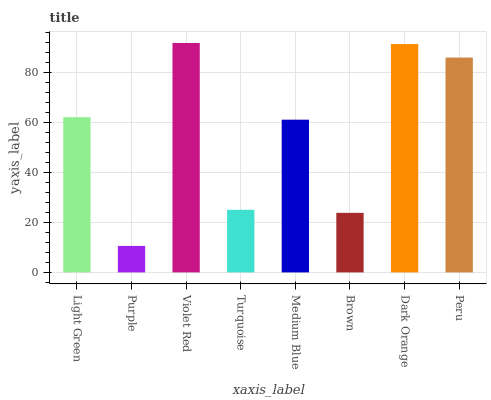Is Purple the minimum?
Answer yes or no. Yes. Is Violet Red the maximum?
Answer yes or no. Yes. Is Violet Red the minimum?
Answer yes or no. No. Is Purple the maximum?
Answer yes or no. No. Is Violet Red greater than Purple?
Answer yes or no. Yes. Is Purple less than Violet Red?
Answer yes or no. Yes. Is Purple greater than Violet Red?
Answer yes or no. No. Is Violet Red less than Purple?
Answer yes or no. No. Is Light Green the high median?
Answer yes or no. Yes. Is Medium Blue the low median?
Answer yes or no. Yes. Is Turquoise the high median?
Answer yes or no. No. Is Brown the low median?
Answer yes or no. No. 